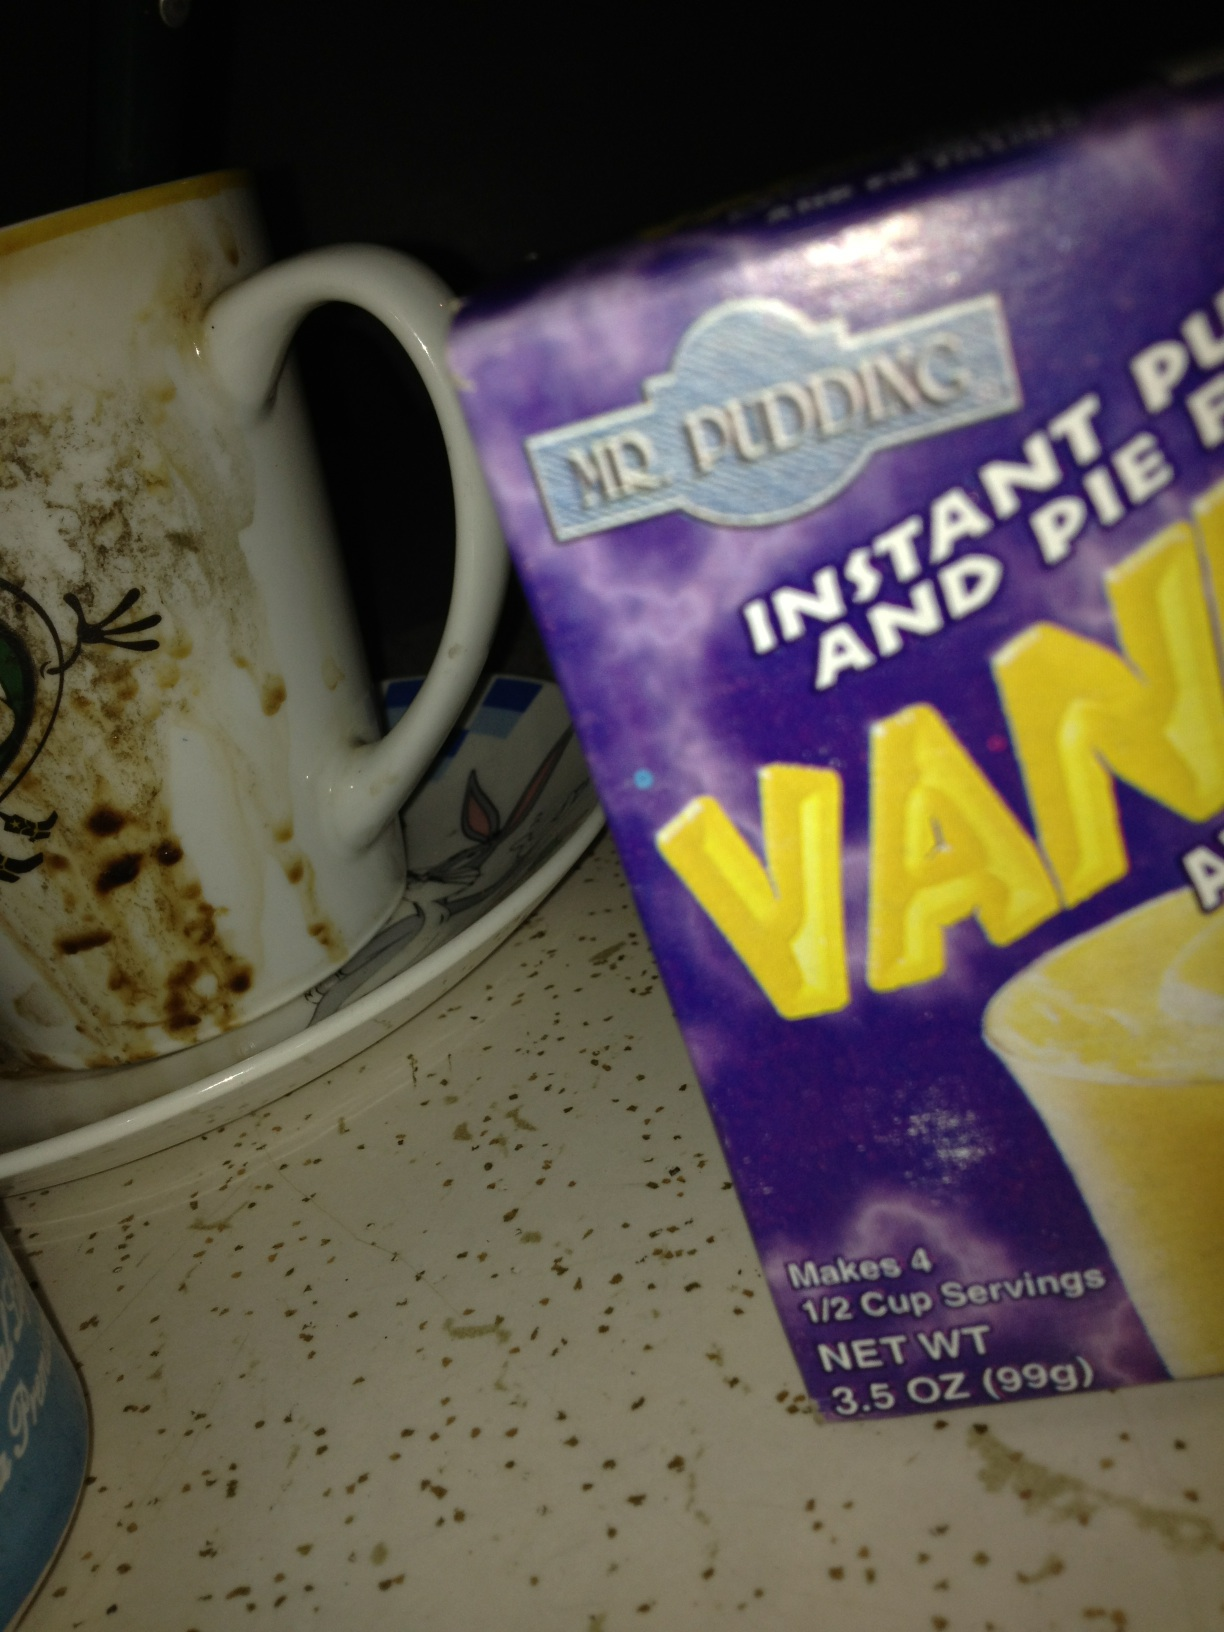What's the state of cleanliness in this area? The image shows a dirty coffee mug and some crumbs or debris on the shelf, indicating that the area could benefit from cleaning. Maintaining cleanliness is important for food safety and overall hygiene. 